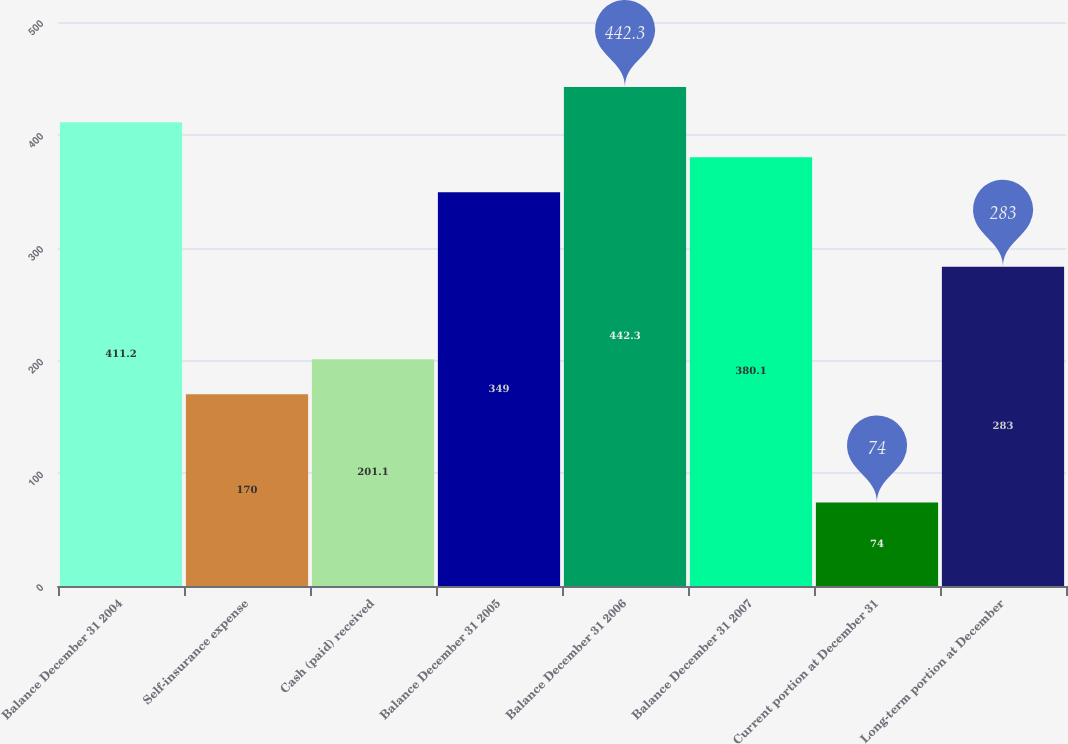<chart> <loc_0><loc_0><loc_500><loc_500><bar_chart><fcel>Balance December 31 2004<fcel>Self-insurance expense<fcel>Cash (paid) received<fcel>Balance December 31 2005<fcel>Balance December 31 2006<fcel>Balance December 31 2007<fcel>Current portion at December 31<fcel>Long-term portion at December<nl><fcel>411.2<fcel>170<fcel>201.1<fcel>349<fcel>442.3<fcel>380.1<fcel>74<fcel>283<nl></chart> 